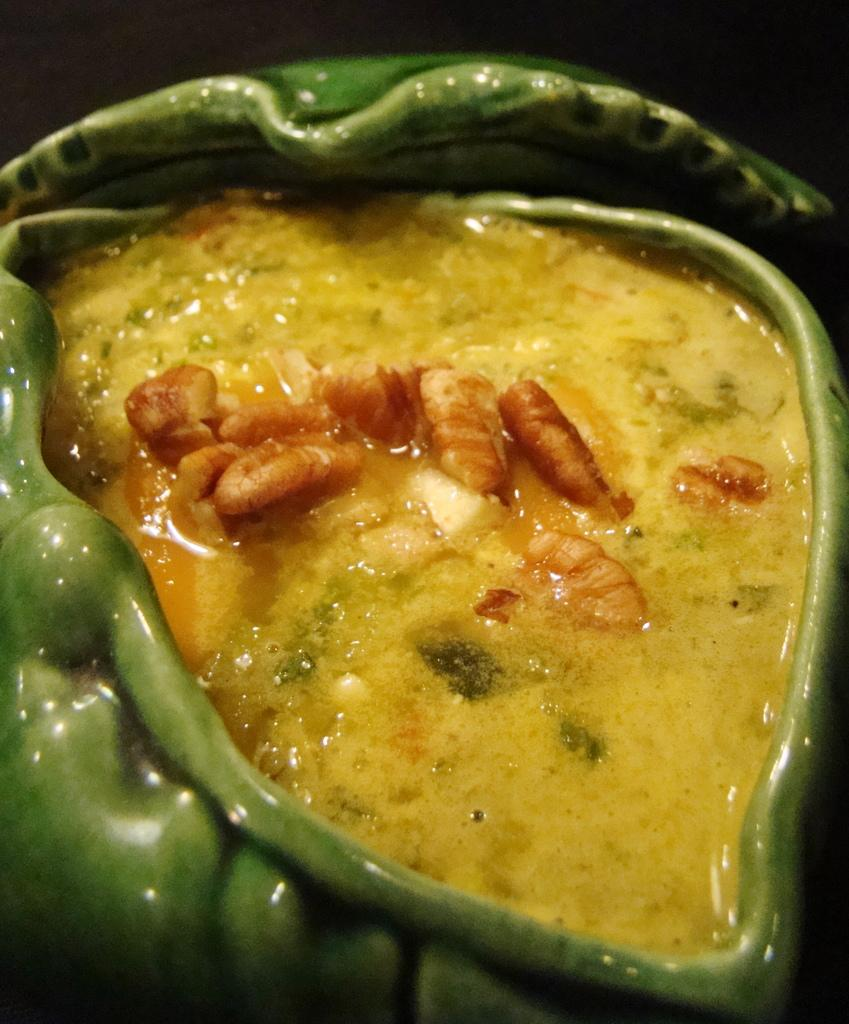What type of cooked food can be seen in the image? The image contains a cooked food item, but the specific type is not mentioned in the facts. How is the cooked food item presented in the image? The cooked food item is served in a bowl. What type of toys can be seen in the image? There are no toys present in the image. Is there a calculator visible in the image? There is no calculator present in the image. 